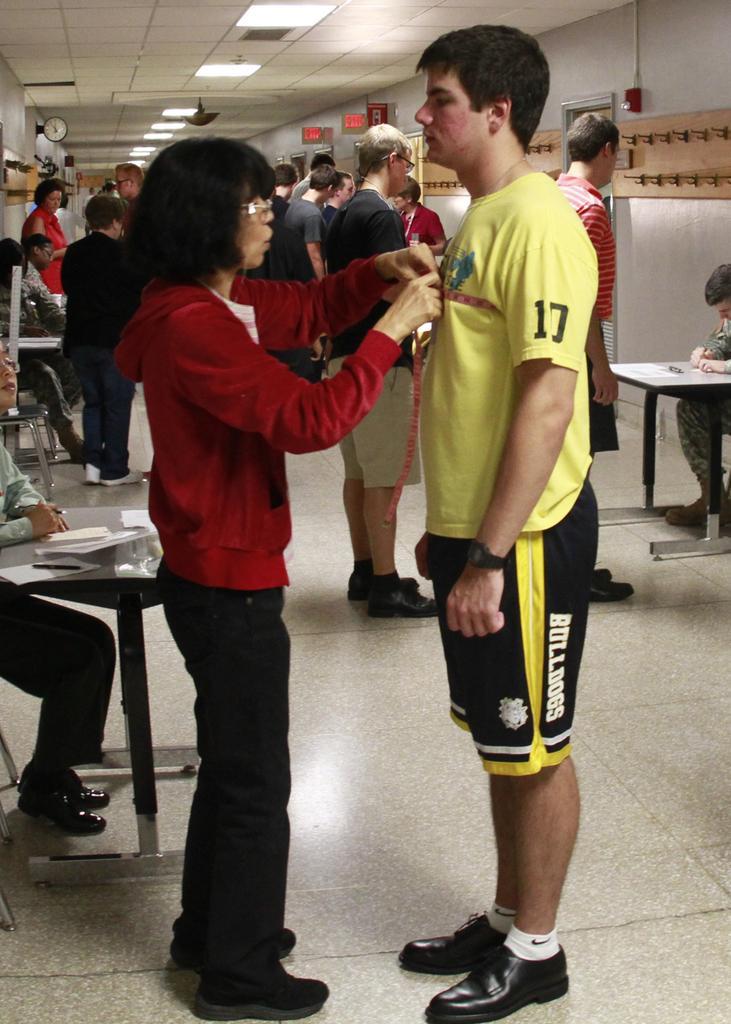How would you summarize this image in a sentence or two? In this picture there is a woman and a man standing. Woman is holding a object in her hands. In the backdrop there are many people standing. 